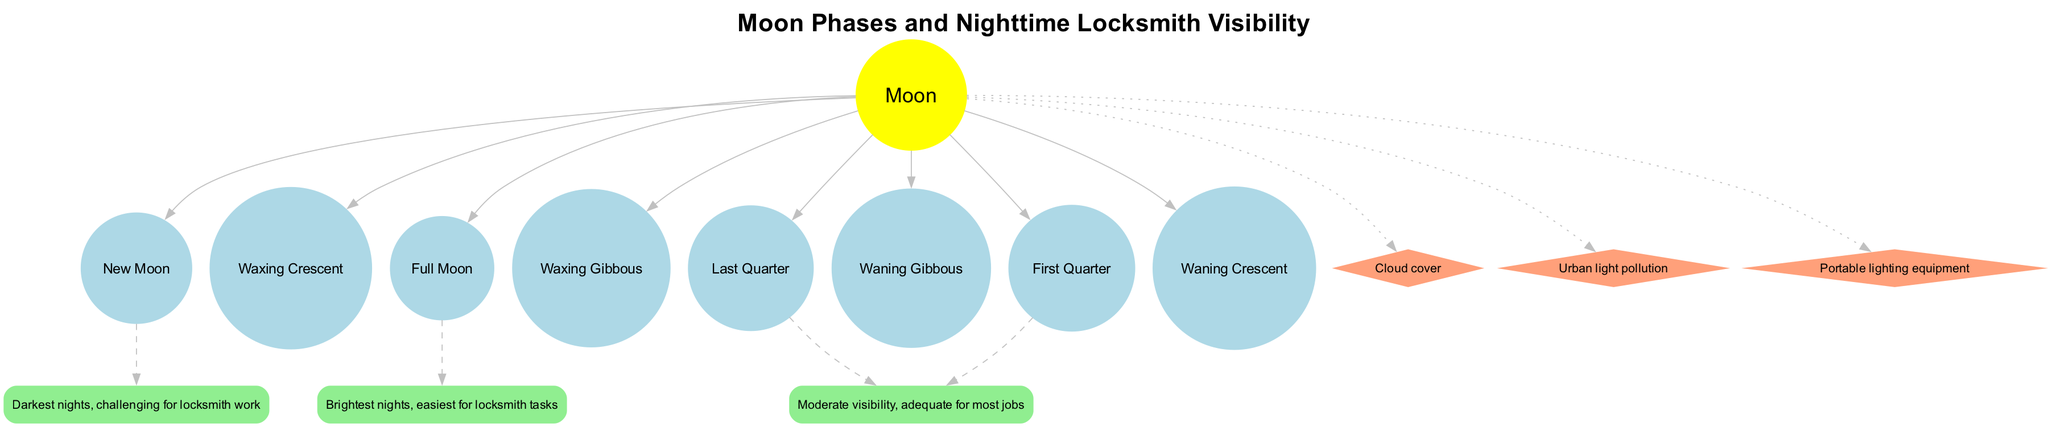What are the eight phases of the Moon listed in the diagram? The diagram clearly enumerates the eight specific phases displayed in a list format. These phases are: New Moon, Waxing Crescent, First Quarter, Waxing Gibbous, Full Moon, Waning Gibbous, Last Quarter, Waning Crescent.
Answer: New Moon, Waxing Crescent, First Quarter, Waxing Gibbous, Full Moon, Waning Gibbous, Last Quarter, Waning Crescent Which Moon phase is associated with the brightest nights? In the visibility impacts section of the diagram, it is indicated that the Full Moon phase provides the brightest nights, making it the ideal time for locksmith tasks.
Answer: Full Moon How many visibility impacts are linked to specific Moon phases? The diagram contains four specific visibility impacts that correlate with certain Moon phases, namely New Moon, Full Moon, First Quarter, and Last Quarter.
Answer: Four What is the visibility impact associated with the New Moon? The visibility impact for the New Moon, as represented in the diagram, indicates that it leads to the darkest nights, thereby presenting challenges for locksmith work.
Answer: Darkest nights, challenging for locksmith work Which phase of the Moon has moderate visibility? The diagram indicates that both the First Quarter and Last Quarter phases are categorized under moderate visibility impacts, making them adequate for most locksmith jobs.
Answer: First Quarter and Last Quarter How does cloud cover affect visibility for locksmith tasks according to the diagram? The diagram identifies cloud cover as an additional factor that affects visibility, suggesting that it can potentially hinder the ability to undertake locksmith tasks, especially during less visible Moon phases.
Answer: Hinders visibility How many additional factors are mentioned that impact visibility? The visibility impacts section lists three additional factors influencing visibility: cloud cover, urban light pollution, and portable lighting equipment, therefore the total number mentioned is three.
Answer: Three If the Moon is at the Waxing Crescent phase, what can be inferred about the visibility for locksmith tasks? While the diagram does not specify visibility impacts for the Waxing Crescent phase directly, it is reasonable to deduce that since it is not explicitly marked as either "dark" or "bright," it would likely yield better visibility than a New Moon but not as bright as a Full Moon, indicating that visibility could be moderate.
Answer: Moderate visibility (implied) 